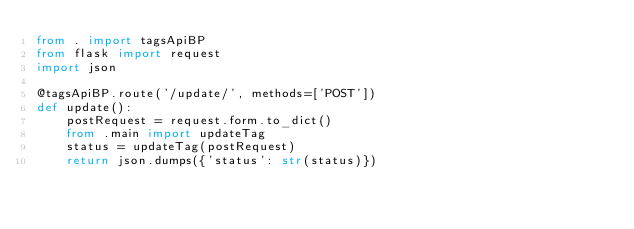<code> <loc_0><loc_0><loc_500><loc_500><_Python_>from . import tagsApiBP
from flask import request
import json

@tagsApiBP.route('/update/', methods=['POST'])
def update():
    postRequest = request.form.to_dict()
    from .main import updateTag
    status = updateTag(postRequest)
    return json.dumps({'status': str(status)})
</code> 